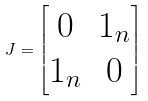Convert formula to latex. <formula><loc_0><loc_0><loc_500><loc_500>J = \begin{bmatrix} 0 & 1 _ { n } \\ 1 _ { n } & 0 \end{bmatrix}</formula> 